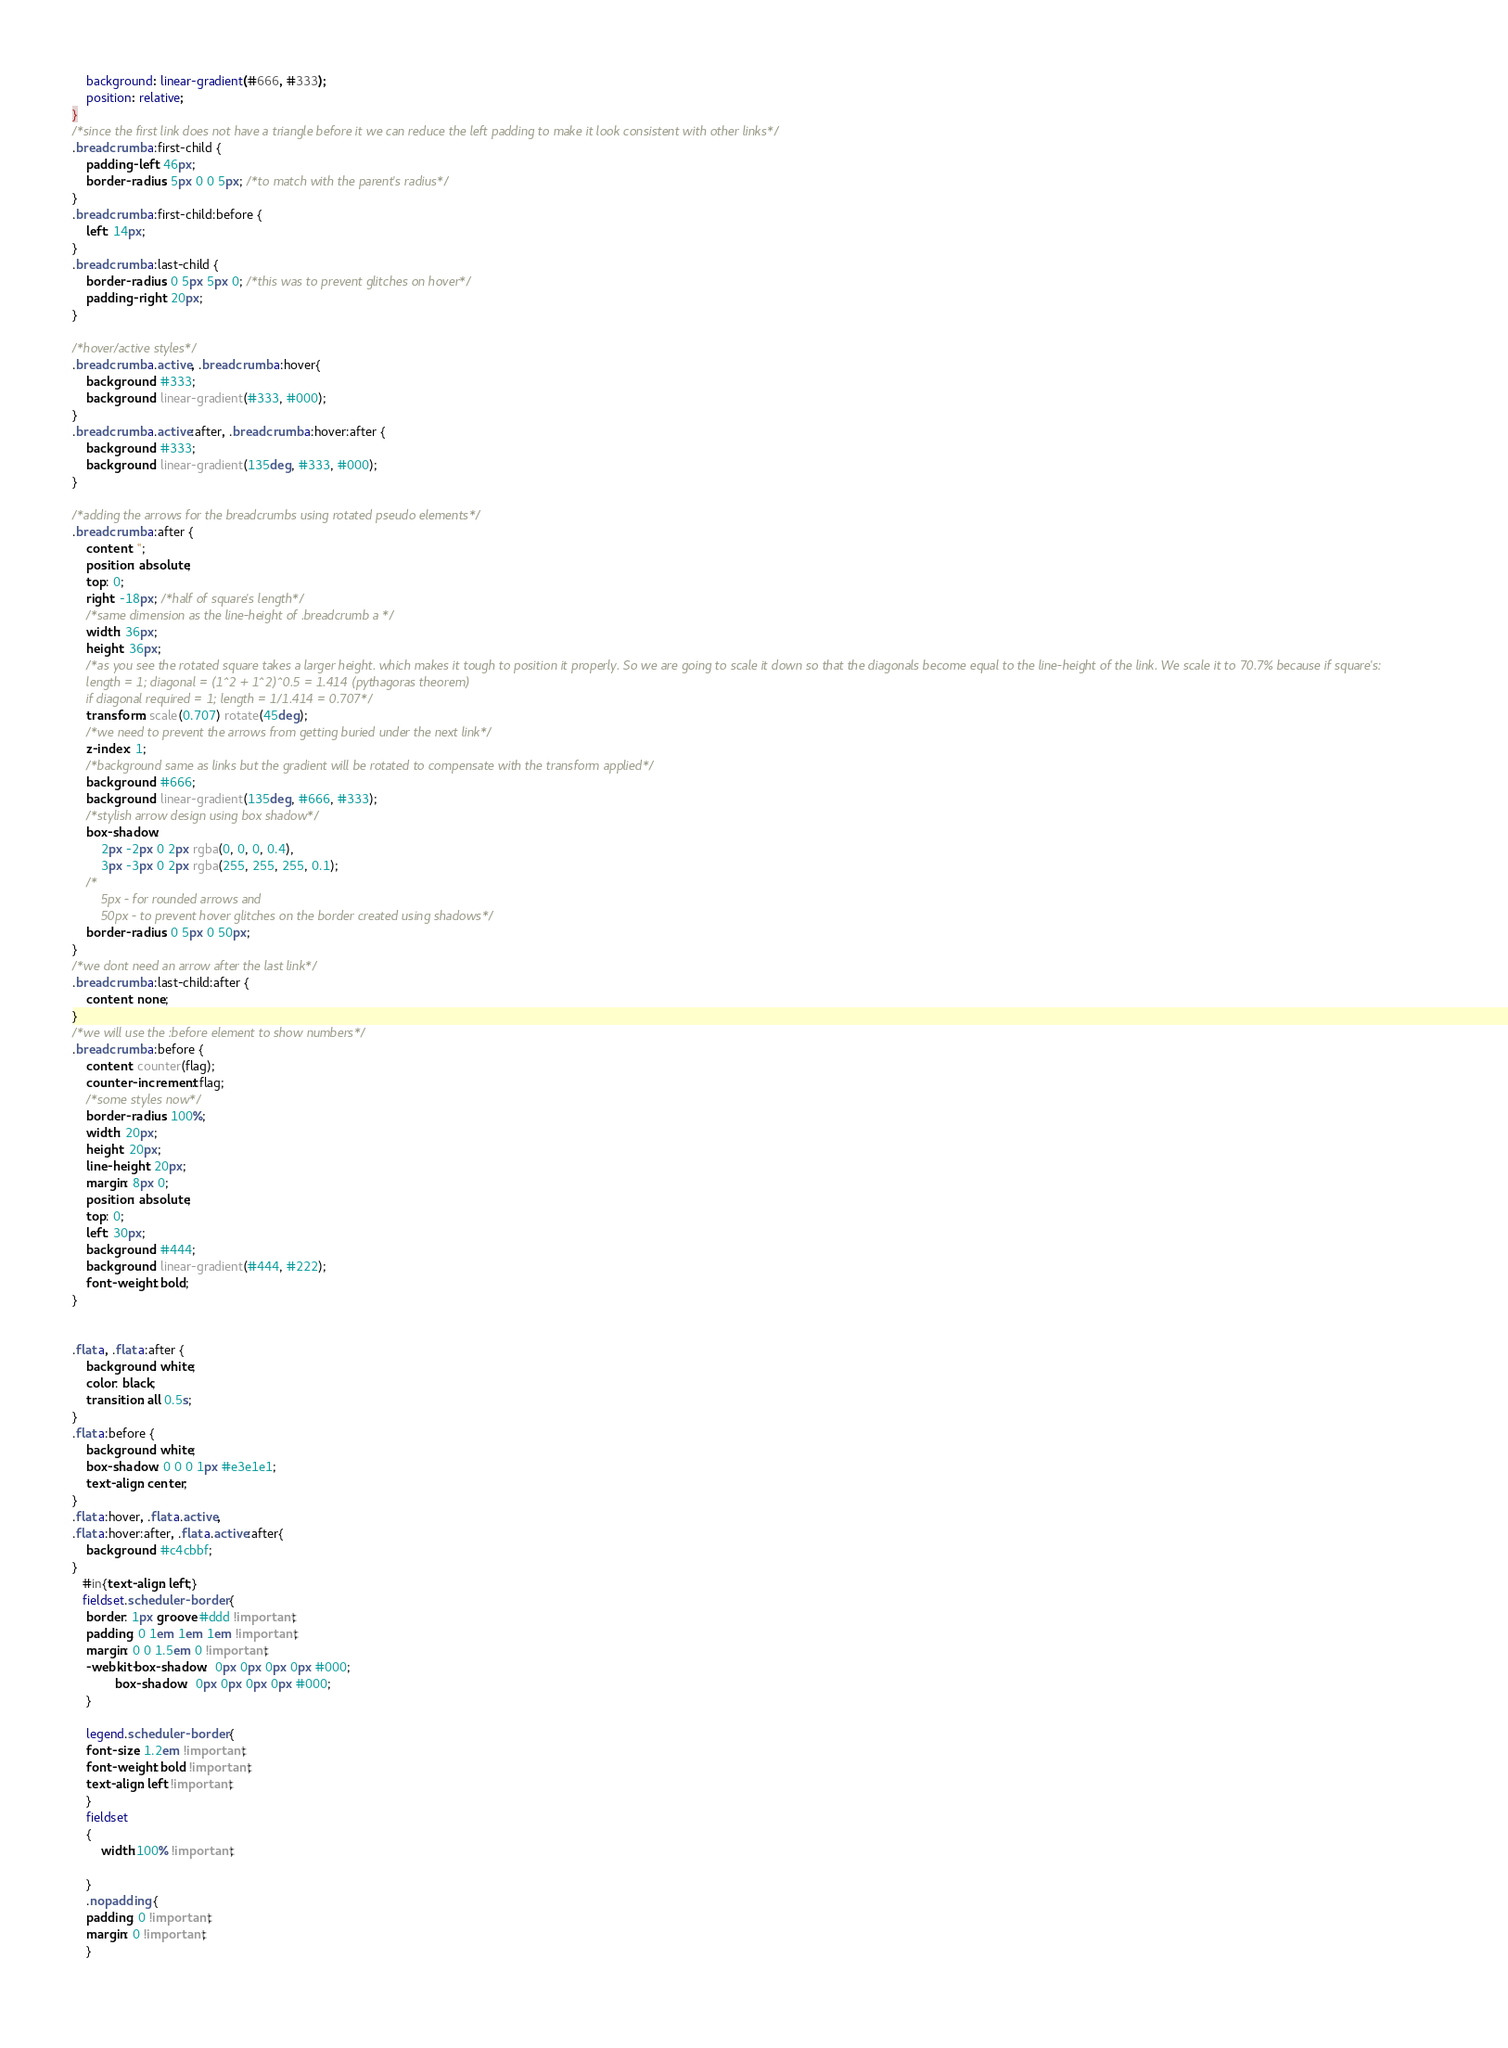<code> <loc_0><loc_0><loc_500><loc_500><_CSS_>	background: linear-gradient(#666, #333);
	position: relative;
}
/*since the first link does not have a triangle before it we can reduce the left padding to make it look consistent with other links*/
.breadcrumb a:first-child {
	padding-left: 46px;
	border-radius: 5px 0 0 5px; /*to match with the parent's radius*/
}
.breadcrumb a:first-child:before {
	left: 14px;
}
.breadcrumb a:last-child {
	border-radius: 0 5px 5px 0; /*this was to prevent glitches on hover*/
	padding-right: 20px;
}

/*hover/active styles*/
.breadcrumb a.active, .breadcrumb a:hover{
	background: #333;
	background: linear-gradient(#333, #000);
}
.breadcrumb a.active:after, .breadcrumb a:hover:after {
	background: #333;
	background: linear-gradient(135deg, #333, #000);
}

/*adding the arrows for the breadcrumbs using rotated pseudo elements*/
.breadcrumb a:after {
	content: '';
	position: absolute;
	top: 0; 
	right: -18px; /*half of square's length*/
	/*same dimension as the line-height of .breadcrumb a */
	width: 36px; 
	height: 36px;
	/*as you see the rotated square takes a larger height. which makes it tough to position it properly. So we are going to scale it down so that the diagonals become equal to the line-height of the link. We scale it to 70.7% because if square's: 
	length = 1; diagonal = (1^2 + 1^2)^0.5 = 1.414 (pythagoras theorem)
	if diagonal required = 1; length = 1/1.414 = 0.707*/
	transform: scale(0.707) rotate(45deg);
	/*we need to prevent the arrows from getting buried under the next link*/
	z-index: 1;
	/*background same as links but the gradient will be rotated to compensate with the transform applied*/
	background: #666;
	background: linear-gradient(135deg, #666, #333);
	/*stylish arrow design using box shadow*/
	box-shadow: 
		2px -2px 0 2px rgba(0, 0, 0, 0.4), 
		3px -3px 0 2px rgba(255, 255, 255, 0.1);
	/*
		5px - for rounded arrows and 
		50px - to prevent hover glitches on the border created using shadows*/
	border-radius: 0 5px 0 50px;
}
/*we dont need an arrow after the last link*/
.breadcrumb a:last-child:after {
	content: none;
}
/*we will use the :before element to show numbers*/
.breadcrumb a:before {
	content: counter(flag);
	counter-increment: flag;
	/*some styles now*/
	border-radius: 100%;
	width: 20px;
	height: 20px;
	line-height: 20px;
	margin: 8px 0;
	position: absolute;
	top: 0;
	left: 30px;
	background: #444;
	background: linear-gradient(#444, #222);
	font-weight: bold;
}


.flat a, .flat a:after {
	background: white;
	color: black;
	transition: all 0.5s;
}
.flat a:before {
	background: white;
	box-shadow: 0 0 0 1px #e3e1e1;
    text-align: center;
}
.flat a:hover, .flat a.active, 
.flat a:hover:after, .flat a.active:after{
	background: #c4cbbf;
}
   #in{text-align: left;}
   fieldset.scheduler-border {
    border: 1px groove #ddd !important;
    padding: 0 1em 1em 1em !important;
    margin: 0 0 1.5em 0 !important;
    -webkit-box-shadow:  0px 0px 0px 0px #000;
            box-shadow:  0px 0px 0px 0px #000;
    }

    legend.scheduler-border {
    font-size: 1.2em !important;
    font-weight: bold !important;
    text-align: left !important;
    }
    fieldset
    {
        width:100% !important;
        
    }
    .nopadding {
    padding: 0 !important;
    margin: 0 !important;
    }
 </code> 